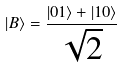Convert formula to latex. <formula><loc_0><loc_0><loc_500><loc_500>| B \rangle = \frac { | 0 1 \rangle + | 1 0 \rangle } { \sqrt { 2 } }</formula> 